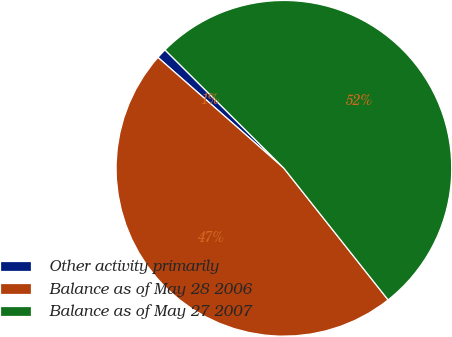Convert chart to OTSL. <chart><loc_0><loc_0><loc_500><loc_500><pie_chart><fcel>Other activity primarily<fcel>Balance as of May 28 2006<fcel>Balance as of May 27 2007<nl><fcel>0.98%<fcel>47.14%<fcel>51.87%<nl></chart> 